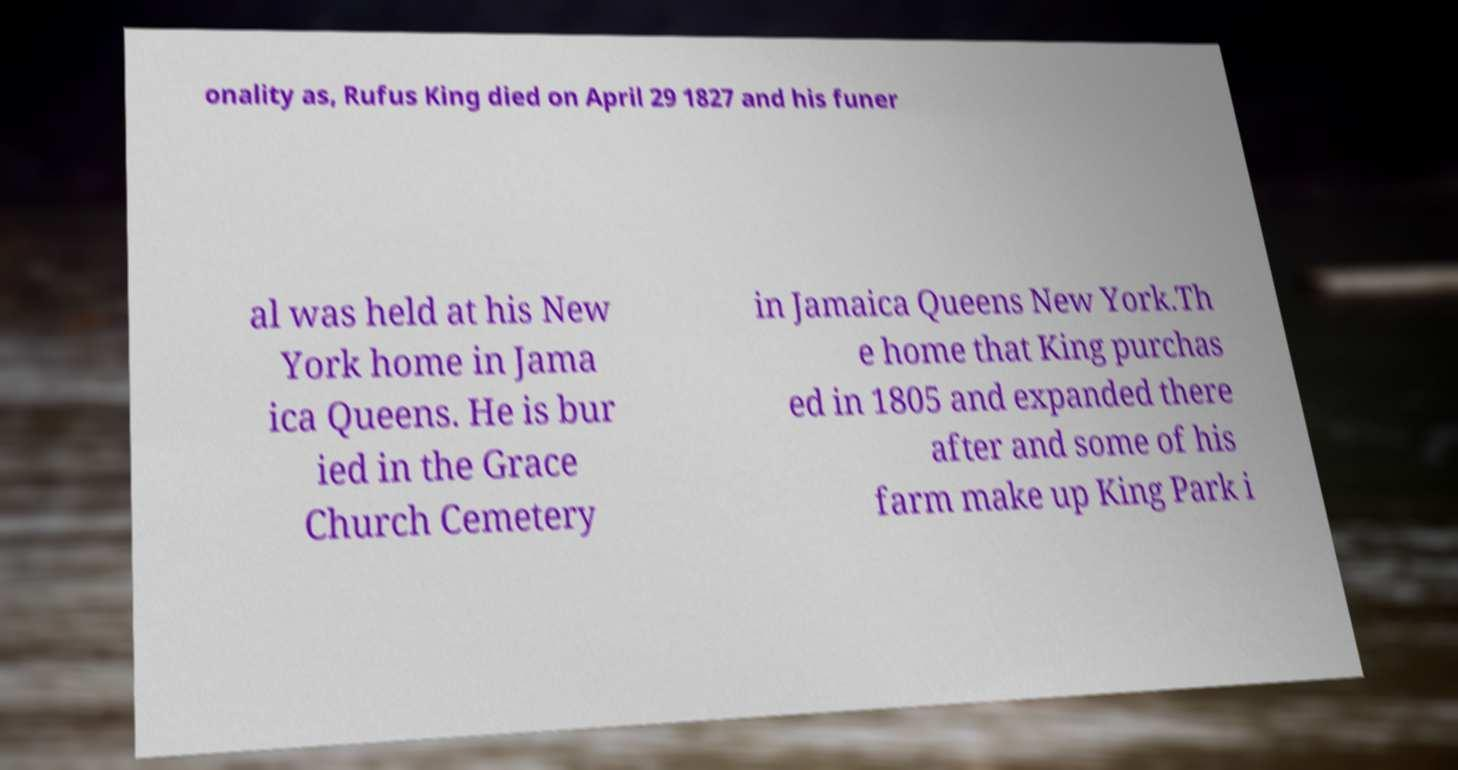Can you read and provide the text displayed in the image?This photo seems to have some interesting text. Can you extract and type it out for me? onality as, Rufus King died on April 29 1827 and his funer al was held at his New York home in Jama ica Queens. He is bur ied in the Grace Church Cemetery in Jamaica Queens New York.Th e home that King purchas ed in 1805 and expanded there after and some of his farm make up King Park i 